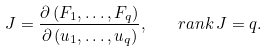<formula> <loc_0><loc_0><loc_500><loc_500>J = \frac { \partial \left ( F _ { 1 } , \dots , F _ { q } \right ) } { \partial \left ( u _ { 1 } , \dots , u _ { q } \right ) } , \quad r a n k \, J = q .</formula> 